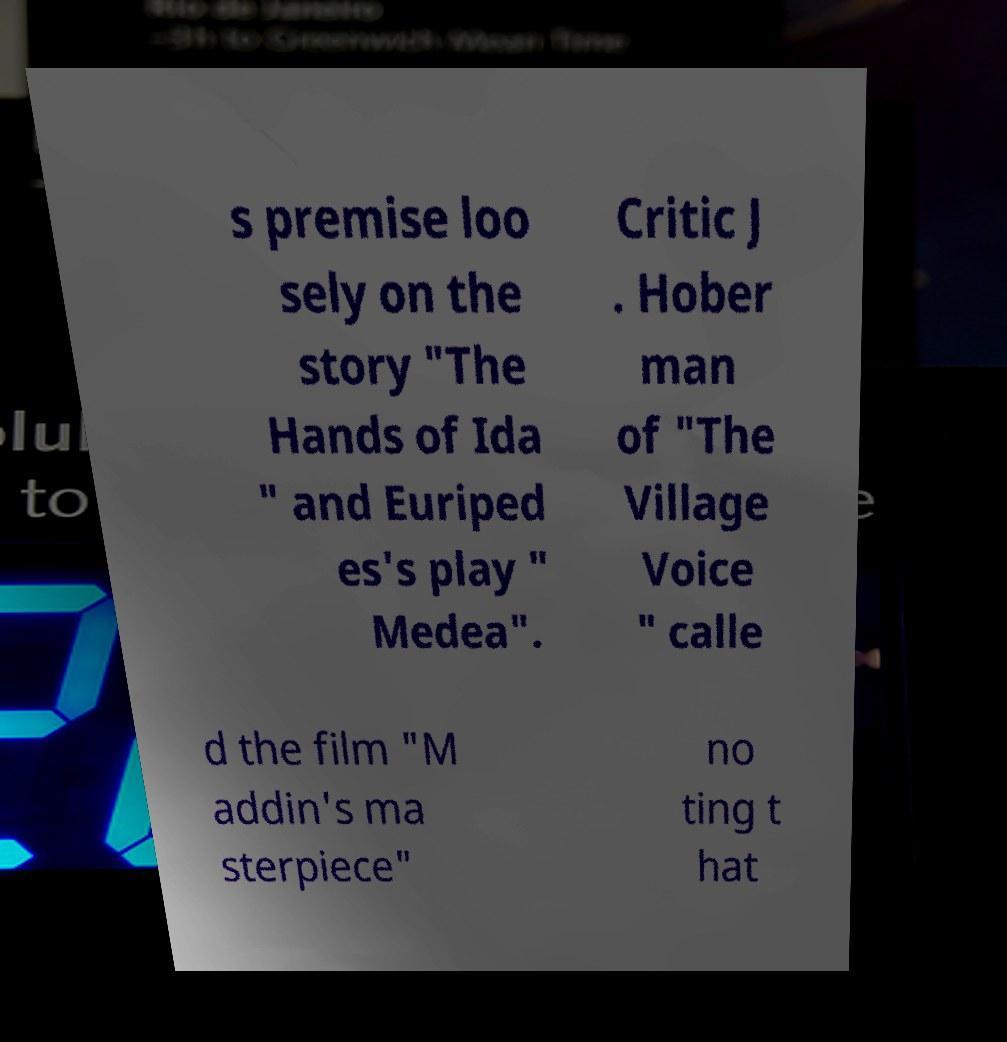I need the written content from this picture converted into text. Can you do that? s premise loo sely on the story "The Hands of Ida " and Euriped es's play " Medea". Critic J . Hober man of "The Village Voice " calle d the film "M addin's ma sterpiece" no ting t hat 